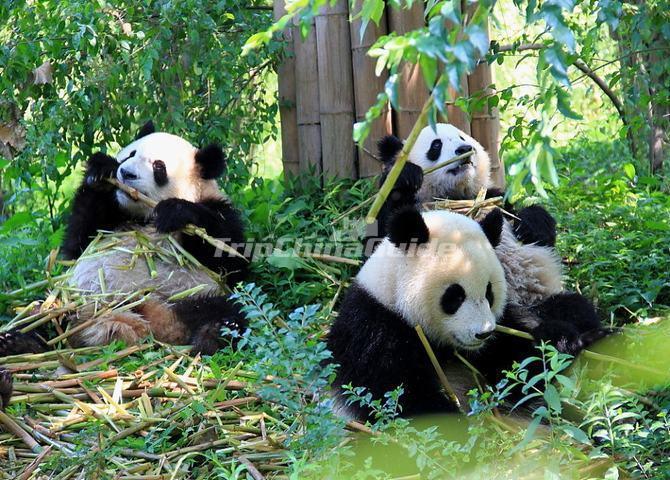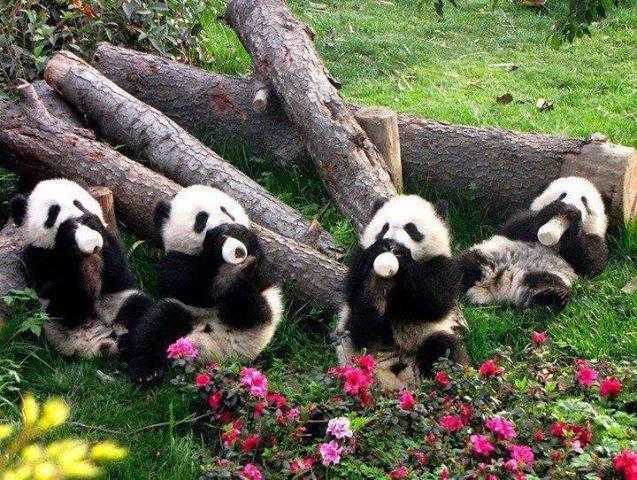The first image is the image on the left, the second image is the image on the right. Given the left and right images, does the statement "In one of the images there are three panda sitting and eating bamboo." hold true? Answer yes or no. Yes. The first image is the image on the left, the second image is the image on the right. Examine the images to the left and right. Is the description "An image shows multiple pandas sitting among foliage and chewing on stalks." accurate? Answer yes or no. Yes. 